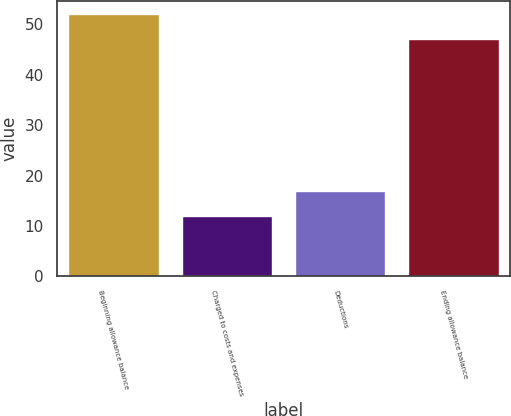Convert chart to OTSL. <chart><loc_0><loc_0><loc_500><loc_500><bar_chart><fcel>Beginning allowance balance<fcel>Charged to costs and expenses<fcel>Deductions<fcel>Ending allowance balance<nl><fcel>52<fcel>12<fcel>17<fcel>47<nl></chart> 